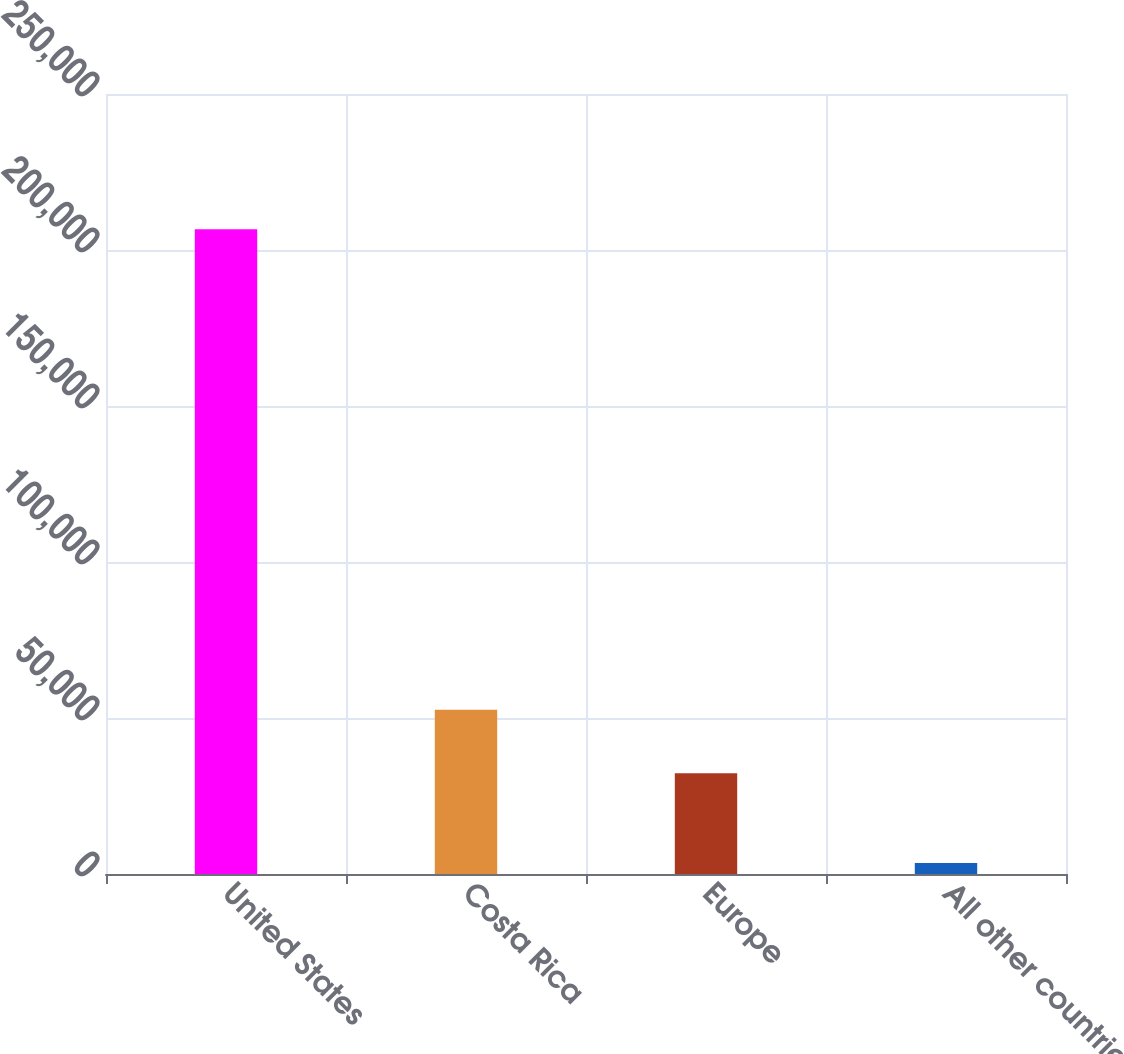<chart> <loc_0><loc_0><loc_500><loc_500><bar_chart><fcel>United States<fcel>Costa Rica<fcel>Europe<fcel>All other countries<nl><fcel>206630<fcel>52637.7<fcel>32328<fcel>3533<nl></chart> 